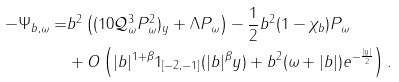Convert formula to latex. <formula><loc_0><loc_0><loc_500><loc_500>- \Psi _ { b , \omega } = & b ^ { 2 } \left ( ( 1 0 \mathcal { Q } _ { \omega } ^ { 3 } P _ { \omega } ^ { 2 } ) _ { y } + \Lambda P _ { \omega } \right ) - \frac { 1 } { 2 } b ^ { 2 } ( 1 - \chi _ { b } ) P _ { \omega } \\ & + O \left ( | b | ^ { 1 + \beta } 1 _ { [ - 2 , - 1 ] } ( | b | ^ { \beta } y ) + b ^ { 2 } ( \omega + | b | ) e ^ { - \frac { | y | } { 2 } } \right ) .</formula> 